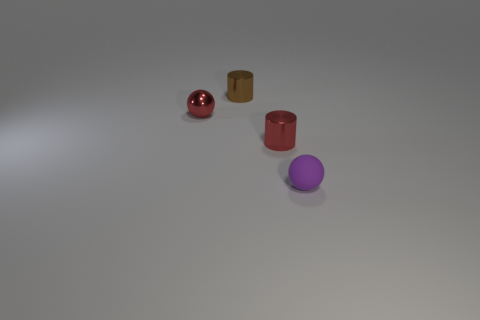Add 1 small red metallic balls. How many objects exist? 5 Subtract all tiny cylinders. Subtract all tiny yellow metal cubes. How many objects are left? 2 Add 4 tiny brown things. How many tiny brown things are left? 5 Add 2 small metallic balls. How many small metallic balls exist? 3 Subtract 0 purple cylinders. How many objects are left? 4 